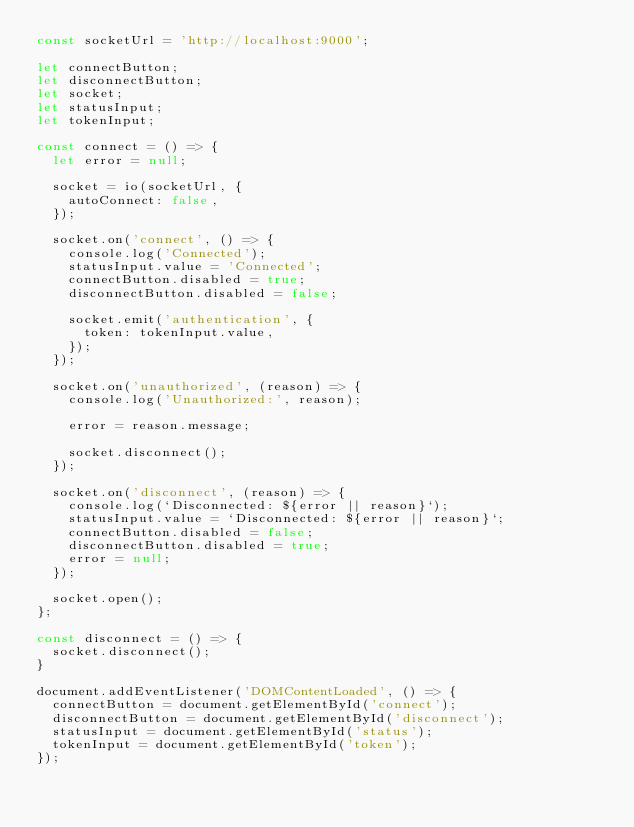<code> <loc_0><loc_0><loc_500><loc_500><_JavaScript_>const socketUrl = 'http://localhost:9000';

let connectButton;
let disconnectButton;
let socket;
let statusInput;
let tokenInput;

const connect = () => {
  let error = null;

  socket = io(socketUrl, {
    autoConnect: false,
  });

  socket.on('connect', () => {
    console.log('Connected');
    statusInput.value = 'Connected';
    connectButton.disabled = true;
    disconnectButton.disabled = false;

    socket.emit('authentication', {
      token: tokenInput.value,
    });
  });

  socket.on('unauthorized', (reason) => {
    console.log('Unauthorized:', reason);

    error = reason.message;

    socket.disconnect();
  });

  socket.on('disconnect', (reason) => {
    console.log(`Disconnected: ${error || reason}`);
    statusInput.value = `Disconnected: ${error || reason}`;
    connectButton.disabled = false;
    disconnectButton.disabled = true;
    error = null;
  });

  socket.open();
};

const disconnect = () => {
  socket.disconnect();
}

document.addEventListener('DOMContentLoaded', () => {
  connectButton = document.getElementById('connect');
  disconnectButton = document.getElementById('disconnect');
  statusInput = document.getElementById('status');
  tokenInput = document.getElementById('token');
});
</code> 